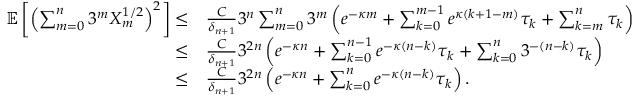Convert formula to latex. <formula><loc_0><loc_0><loc_500><loc_500>\begin{array} { r l } { \mathbb { E } \left [ \left ( \sum _ { m = 0 } ^ { n } 3 ^ { m } X _ { m } ^ { 1 / 2 } \right ) ^ { 2 } \right ] \leq } & { \frac { C } { \delta _ { n + 1 } } 3 ^ { n } \sum _ { m = 0 } ^ { n } 3 ^ { m } \left ( e ^ { - \kappa m } + \sum _ { k = 0 } ^ { m - 1 } e ^ { \kappa ( k + 1 - m ) } \tau _ { k } + \sum _ { k = m } ^ { n } \tau _ { k } \right ) } \\ { \leq } & { \frac { C } { \delta _ { n + 1 } } 3 ^ { 2 n } \left ( e ^ { - \kappa n } + \sum _ { k = 0 } ^ { n - 1 } e ^ { - \kappa ( n - k ) } \tau _ { k } + \sum _ { k = 0 } ^ { n } 3 ^ { - ( n - k ) } \tau _ { k } \right ) } \\ { \leq } & { \frac { C } { \delta _ { n + 1 } } 3 ^ { 2 n } \left ( e ^ { - \kappa n } + \sum _ { k = 0 } ^ { n } e ^ { - \kappa ( n - k ) } \tau _ { k } \right ) . } \end{array}</formula> 